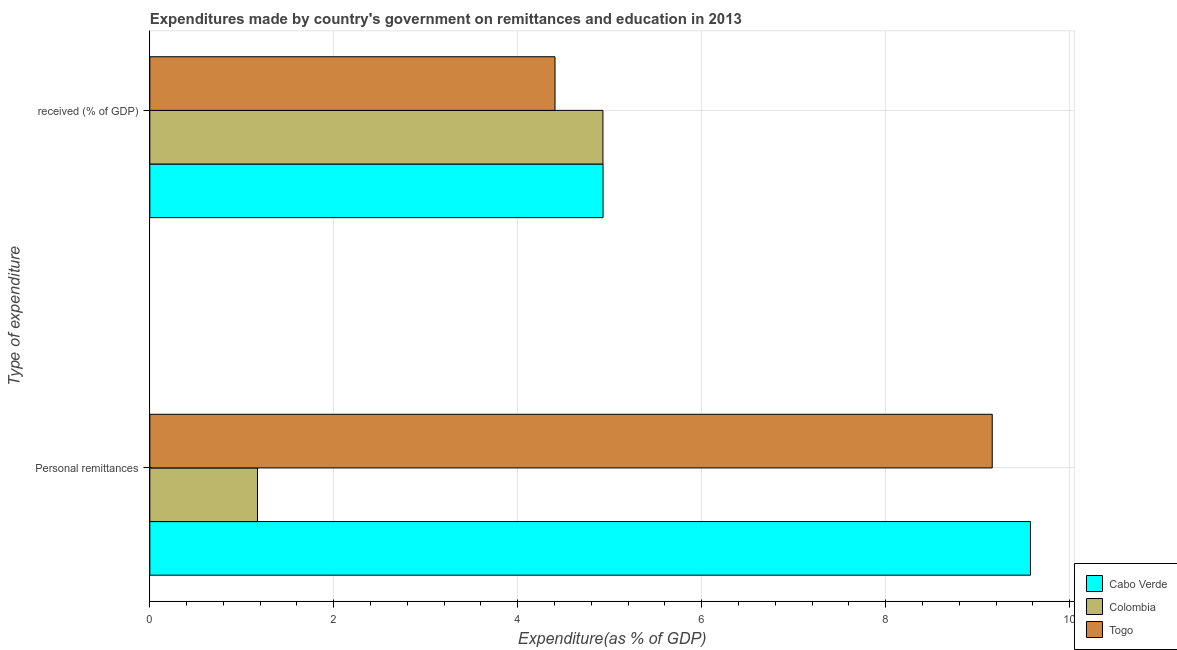How many different coloured bars are there?
Make the answer very short. 3. Are the number of bars per tick equal to the number of legend labels?
Your answer should be very brief. Yes. Are the number of bars on each tick of the Y-axis equal?
Give a very brief answer. Yes. How many bars are there on the 1st tick from the top?
Keep it short and to the point. 3. What is the label of the 1st group of bars from the top?
Provide a short and direct response.  received (% of GDP). What is the expenditure in education in Togo?
Your response must be concise. 4.41. Across all countries, what is the maximum expenditure in personal remittances?
Your answer should be very brief. 9.57. Across all countries, what is the minimum expenditure in education?
Provide a succinct answer. 4.41. In which country was the expenditure in personal remittances maximum?
Your response must be concise. Cabo Verde. What is the total expenditure in education in the graph?
Your answer should be compact. 14.26. What is the difference between the expenditure in education in Togo and that in Cabo Verde?
Your answer should be compact. -0.52. What is the difference between the expenditure in personal remittances in Cabo Verde and the expenditure in education in Togo?
Your answer should be compact. 5.17. What is the average expenditure in personal remittances per country?
Ensure brevity in your answer.  6.63. What is the difference between the expenditure in personal remittances and expenditure in education in Colombia?
Provide a succinct answer. -3.76. What is the ratio of the expenditure in education in Cabo Verde to that in Togo?
Keep it short and to the point. 1.12. Is the expenditure in education in Colombia less than that in Cabo Verde?
Provide a succinct answer. Yes. What does the 3rd bar from the bottom in Personal remittances represents?
Offer a very short reply. Togo. How many bars are there?
Provide a short and direct response. 6. Are all the bars in the graph horizontal?
Give a very brief answer. Yes. What is the difference between two consecutive major ticks on the X-axis?
Your answer should be very brief. 2. Are the values on the major ticks of X-axis written in scientific E-notation?
Ensure brevity in your answer.  No. How are the legend labels stacked?
Provide a short and direct response. Vertical. What is the title of the graph?
Keep it short and to the point. Expenditures made by country's government on remittances and education in 2013. What is the label or title of the X-axis?
Give a very brief answer. Expenditure(as % of GDP). What is the label or title of the Y-axis?
Provide a short and direct response. Type of expenditure. What is the Expenditure(as % of GDP) of Cabo Verde in Personal remittances?
Your answer should be compact. 9.57. What is the Expenditure(as % of GDP) in Colombia in Personal remittances?
Provide a succinct answer. 1.17. What is the Expenditure(as % of GDP) in Togo in Personal remittances?
Your answer should be very brief. 9.16. What is the Expenditure(as % of GDP) in Cabo Verde in  received (% of GDP)?
Offer a terse response. 4.93. What is the Expenditure(as % of GDP) in Colombia in  received (% of GDP)?
Keep it short and to the point. 4.93. What is the Expenditure(as % of GDP) in Togo in  received (% of GDP)?
Offer a very short reply. 4.41. Across all Type of expenditure, what is the maximum Expenditure(as % of GDP) in Cabo Verde?
Provide a succinct answer. 9.57. Across all Type of expenditure, what is the maximum Expenditure(as % of GDP) of Colombia?
Keep it short and to the point. 4.93. Across all Type of expenditure, what is the maximum Expenditure(as % of GDP) of Togo?
Keep it short and to the point. 9.16. Across all Type of expenditure, what is the minimum Expenditure(as % of GDP) of Cabo Verde?
Offer a terse response. 4.93. Across all Type of expenditure, what is the minimum Expenditure(as % of GDP) in Colombia?
Offer a very short reply. 1.17. Across all Type of expenditure, what is the minimum Expenditure(as % of GDP) of Togo?
Offer a very short reply. 4.41. What is the total Expenditure(as % of GDP) of Cabo Verde in the graph?
Your response must be concise. 14.5. What is the total Expenditure(as % of GDP) in Colombia in the graph?
Offer a terse response. 6.1. What is the total Expenditure(as % of GDP) of Togo in the graph?
Make the answer very short. 13.56. What is the difference between the Expenditure(as % of GDP) of Cabo Verde in Personal remittances and that in  received (% of GDP)?
Offer a very short reply. 4.65. What is the difference between the Expenditure(as % of GDP) in Colombia in Personal remittances and that in  received (% of GDP)?
Make the answer very short. -3.76. What is the difference between the Expenditure(as % of GDP) of Togo in Personal remittances and that in  received (% of GDP)?
Your response must be concise. 4.75. What is the difference between the Expenditure(as % of GDP) of Cabo Verde in Personal remittances and the Expenditure(as % of GDP) of Colombia in  received (% of GDP)?
Make the answer very short. 4.65. What is the difference between the Expenditure(as % of GDP) of Cabo Verde in Personal remittances and the Expenditure(as % of GDP) of Togo in  received (% of GDP)?
Make the answer very short. 5.17. What is the difference between the Expenditure(as % of GDP) in Colombia in Personal remittances and the Expenditure(as % of GDP) in Togo in  received (% of GDP)?
Make the answer very short. -3.23. What is the average Expenditure(as % of GDP) in Cabo Verde per Type of expenditure?
Offer a terse response. 7.25. What is the average Expenditure(as % of GDP) of Colombia per Type of expenditure?
Offer a very short reply. 3.05. What is the average Expenditure(as % of GDP) of Togo per Type of expenditure?
Give a very brief answer. 6.78. What is the difference between the Expenditure(as % of GDP) of Cabo Verde and Expenditure(as % of GDP) of Colombia in Personal remittances?
Your answer should be compact. 8.4. What is the difference between the Expenditure(as % of GDP) of Cabo Verde and Expenditure(as % of GDP) of Togo in Personal remittances?
Keep it short and to the point. 0.42. What is the difference between the Expenditure(as % of GDP) of Colombia and Expenditure(as % of GDP) of Togo in Personal remittances?
Make the answer very short. -7.99. What is the difference between the Expenditure(as % of GDP) in Cabo Verde and Expenditure(as % of GDP) in Colombia in  received (% of GDP)?
Provide a succinct answer. 0. What is the difference between the Expenditure(as % of GDP) in Cabo Verde and Expenditure(as % of GDP) in Togo in  received (% of GDP)?
Keep it short and to the point. 0.52. What is the difference between the Expenditure(as % of GDP) in Colombia and Expenditure(as % of GDP) in Togo in  received (% of GDP)?
Keep it short and to the point. 0.52. What is the ratio of the Expenditure(as % of GDP) in Cabo Verde in Personal remittances to that in  received (% of GDP)?
Offer a very short reply. 1.94. What is the ratio of the Expenditure(as % of GDP) of Colombia in Personal remittances to that in  received (% of GDP)?
Offer a very short reply. 0.24. What is the ratio of the Expenditure(as % of GDP) of Togo in Personal remittances to that in  received (% of GDP)?
Provide a succinct answer. 2.08. What is the difference between the highest and the second highest Expenditure(as % of GDP) in Cabo Verde?
Offer a very short reply. 4.65. What is the difference between the highest and the second highest Expenditure(as % of GDP) in Colombia?
Give a very brief answer. 3.76. What is the difference between the highest and the second highest Expenditure(as % of GDP) in Togo?
Provide a succinct answer. 4.75. What is the difference between the highest and the lowest Expenditure(as % of GDP) of Cabo Verde?
Your answer should be compact. 4.65. What is the difference between the highest and the lowest Expenditure(as % of GDP) in Colombia?
Your response must be concise. 3.76. What is the difference between the highest and the lowest Expenditure(as % of GDP) in Togo?
Offer a terse response. 4.75. 